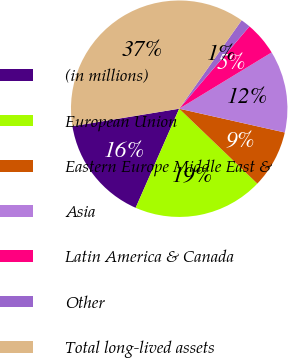<chart> <loc_0><loc_0><loc_500><loc_500><pie_chart><fcel>(in millions)<fcel>European Union<fcel>Eastern Europe Middle East &<fcel>Asia<fcel>Latin America & Canada<fcel>Other<fcel>Total long-lived assets<nl><fcel>15.82%<fcel>19.42%<fcel>8.64%<fcel>12.23%<fcel>5.05%<fcel>1.46%<fcel>37.37%<nl></chart> 